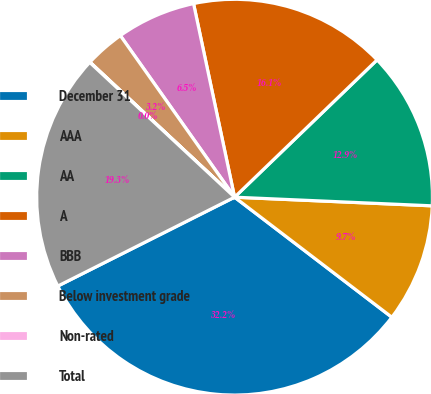Convert chart. <chart><loc_0><loc_0><loc_500><loc_500><pie_chart><fcel>December 31<fcel>AAA<fcel>AA<fcel>A<fcel>BBB<fcel>Below investment grade<fcel>Non-rated<fcel>Total<nl><fcel>32.21%<fcel>9.68%<fcel>12.9%<fcel>16.12%<fcel>6.47%<fcel>3.25%<fcel>0.03%<fcel>19.34%<nl></chart> 